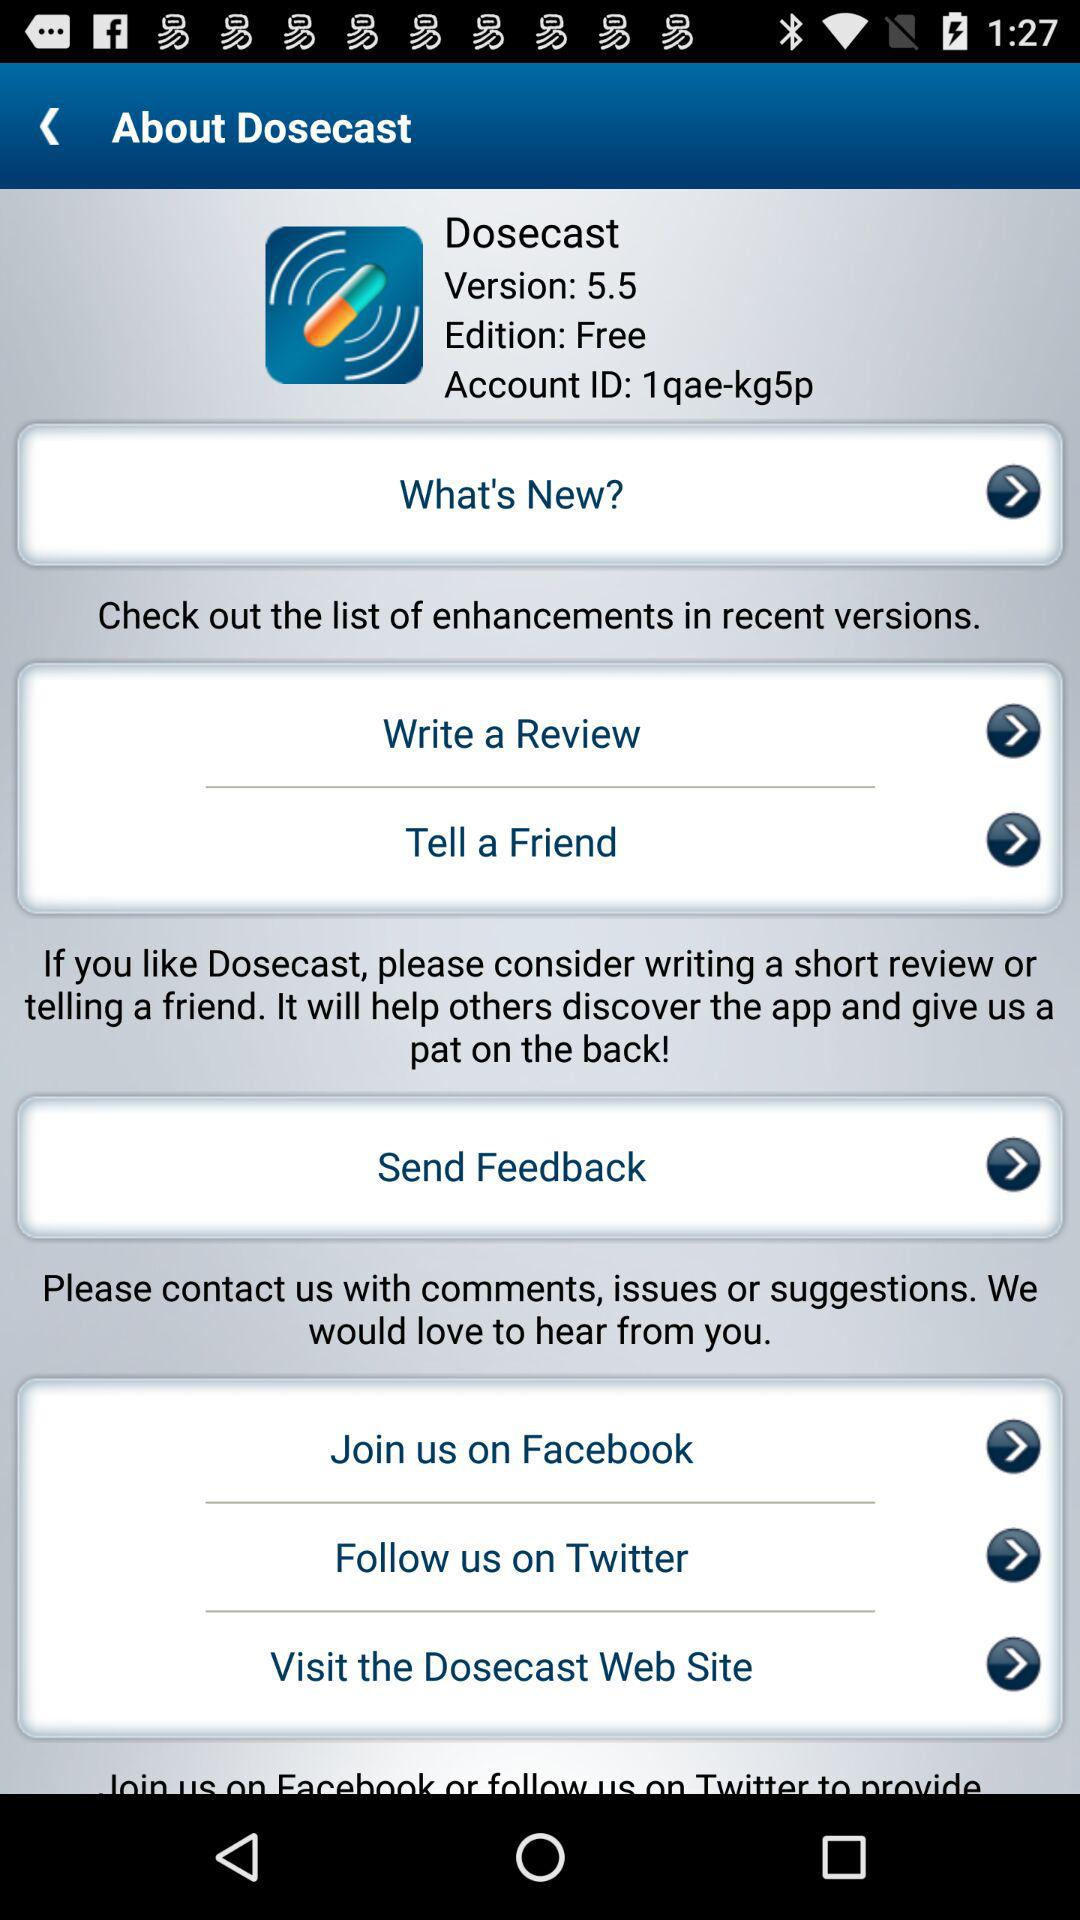Is the edition paid or free? The edition is free. 